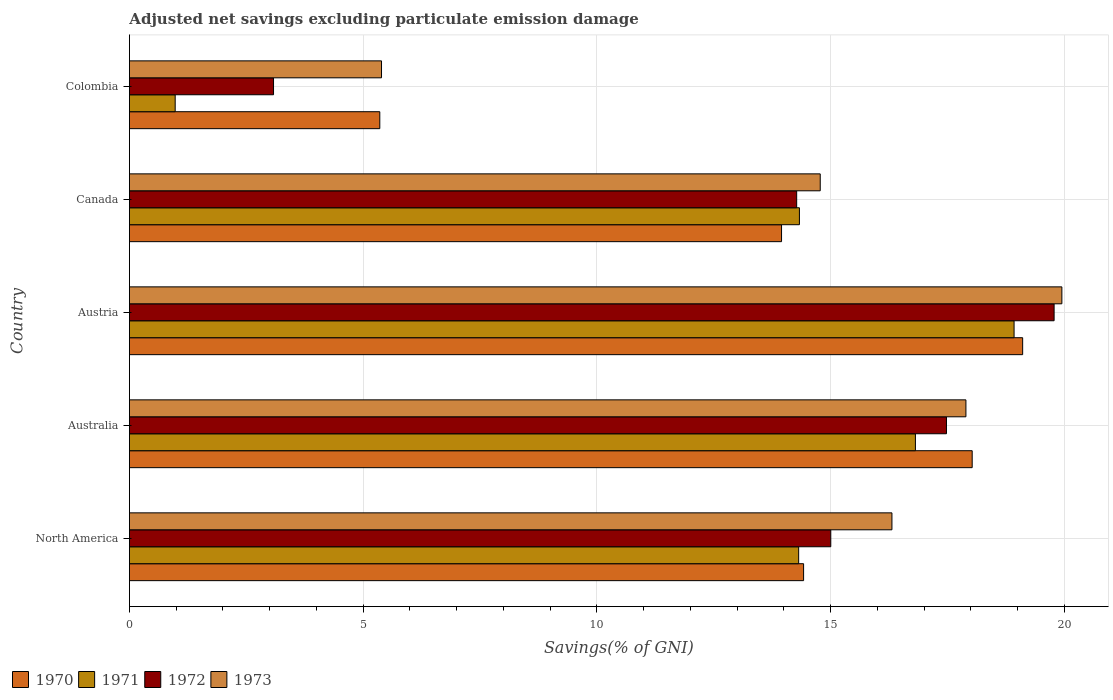Are the number of bars per tick equal to the number of legend labels?
Keep it short and to the point. Yes. In how many cases, is the number of bars for a given country not equal to the number of legend labels?
Keep it short and to the point. 0. What is the adjusted net savings in 1970 in Australia?
Offer a terse response. 18.03. Across all countries, what is the maximum adjusted net savings in 1970?
Provide a succinct answer. 19.11. Across all countries, what is the minimum adjusted net savings in 1973?
Make the answer very short. 5.39. What is the total adjusted net savings in 1973 in the graph?
Your answer should be compact. 74.32. What is the difference between the adjusted net savings in 1971 in Austria and that in Canada?
Provide a succinct answer. 4.59. What is the difference between the adjusted net savings in 1972 in Austria and the adjusted net savings in 1970 in Canada?
Give a very brief answer. 5.83. What is the average adjusted net savings in 1973 per country?
Ensure brevity in your answer.  14.86. What is the difference between the adjusted net savings in 1971 and adjusted net savings in 1972 in Australia?
Ensure brevity in your answer.  -0.66. In how many countries, is the adjusted net savings in 1973 greater than 2 %?
Ensure brevity in your answer.  5. What is the ratio of the adjusted net savings in 1973 in Australia to that in Austria?
Provide a short and direct response. 0.9. Is the adjusted net savings in 1971 in Colombia less than that in North America?
Offer a very short reply. Yes. What is the difference between the highest and the second highest adjusted net savings in 1973?
Keep it short and to the point. 2.05. What is the difference between the highest and the lowest adjusted net savings in 1970?
Make the answer very short. 13.75. Is the sum of the adjusted net savings in 1973 in Australia and Colombia greater than the maximum adjusted net savings in 1971 across all countries?
Keep it short and to the point. Yes. Is it the case that in every country, the sum of the adjusted net savings in 1973 and adjusted net savings in 1972 is greater than the sum of adjusted net savings in 1971 and adjusted net savings in 1970?
Make the answer very short. No. What does the 2nd bar from the bottom in Austria represents?
Your answer should be compact. 1971. Does the graph contain any zero values?
Give a very brief answer. No. Does the graph contain grids?
Your answer should be compact. Yes. Where does the legend appear in the graph?
Make the answer very short. Bottom left. How many legend labels are there?
Make the answer very short. 4. How are the legend labels stacked?
Provide a succinct answer. Horizontal. What is the title of the graph?
Give a very brief answer. Adjusted net savings excluding particulate emission damage. What is the label or title of the X-axis?
Your response must be concise. Savings(% of GNI). What is the Savings(% of GNI) of 1970 in North America?
Make the answer very short. 14.42. What is the Savings(% of GNI) in 1971 in North America?
Provide a short and direct response. 14.31. What is the Savings(% of GNI) of 1972 in North America?
Offer a terse response. 15. What is the Savings(% of GNI) of 1973 in North America?
Provide a short and direct response. 16.31. What is the Savings(% of GNI) in 1970 in Australia?
Provide a short and direct response. 18.03. What is the Savings(% of GNI) of 1971 in Australia?
Give a very brief answer. 16.81. What is the Savings(% of GNI) in 1972 in Australia?
Your answer should be compact. 17.48. What is the Savings(% of GNI) in 1973 in Australia?
Your answer should be compact. 17.89. What is the Savings(% of GNI) of 1970 in Austria?
Your response must be concise. 19.11. What is the Savings(% of GNI) of 1971 in Austria?
Give a very brief answer. 18.92. What is the Savings(% of GNI) of 1972 in Austria?
Your answer should be compact. 19.78. What is the Savings(% of GNI) in 1973 in Austria?
Give a very brief answer. 19.94. What is the Savings(% of GNI) of 1970 in Canada?
Give a very brief answer. 13.95. What is the Savings(% of GNI) in 1971 in Canada?
Your answer should be compact. 14.33. What is the Savings(% of GNI) of 1972 in Canada?
Provide a short and direct response. 14.27. What is the Savings(% of GNI) in 1973 in Canada?
Give a very brief answer. 14.78. What is the Savings(% of GNI) in 1970 in Colombia?
Give a very brief answer. 5.36. What is the Savings(% of GNI) in 1971 in Colombia?
Offer a very short reply. 0.98. What is the Savings(% of GNI) of 1972 in Colombia?
Your response must be concise. 3.08. What is the Savings(% of GNI) in 1973 in Colombia?
Offer a very short reply. 5.39. Across all countries, what is the maximum Savings(% of GNI) of 1970?
Provide a short and direct response. 19.11. Across all countries, what is the maximum Savings(% of GNI) in 1971?
Your answer should be very brief. 18.92. Across all countries, what is the maximum Savings(% of GNI) of 1972?
Offer a terse response. 19.78. Across all countries, what is the maximum Savings(% of GNI) of 1973?
Your response must be concise. 19.94. Across all countries, what is the minimum Savings(% of GNI) in 1970?
Give a very brief answer. 5.36. Across all countries, what is the minimum Savings(% of GNI) of 1971?
Give a very brief answer. 0.98. Across all countries, what is the minimum Savings(% of GNI) of 1972?
Provide a short and direct response. 3.08. Across all countries, what is the minimum Savings(% of GNI) in 1973?
Ensure brevity in your answer.  5.39. What is the total Savings(% of GNI) of 1970 in the graph?
Offer a terse response. 70.86. What is the total Savings(% of GNI) in 1971 in the graph?
Offer a very short reply. 65.36. What is the total Savings(% of GNI) of 1972 in the graph?
Keep it short and to the point. 69.61. What is the total Savings(% of GNI) in 1973 in the graph?
Provide a succinct answer. 74.32. What is the difference between the Savings(% of GNI) of 1970 in North America and that in Australia?
Keep it short and to the point. -3.61. What is the difference between the Savings(% of GNI) of 1971 in North America and that in Australia?
Offer a very short reply. -2.5. What is the difference between the Savings(% of GNI) in 1972 in North America and that in Australia?
Offer a very short reply. -2.47. What is the difference between the Savings(% of GNI) in 1973 in North America and that in Australia?
Offer a very short reply. -1.58. What is the difference between the Savings(% of GNI) of 1970 in North America and that in Austria?
Offer a very short reply. -4.69. What is the difference between the Savings(% of GNI) of 1971 in North America and that in Austria?
Make the answer very short. -4.61. What is the difference between the Savings(% of GNI) in 1972 in North America and that in Austria?
Your response must be concise. -4.78. What is the difference between the Savings(% of GNI) in 1973 in North America and that in Austria?
Give a very brief answer. -3.63. What is the difference between the Savings(% of GNI) in 1970 in North America and that in Canada?
Provide a short and direct response. 0.47. What is the difference between the Savings(% of GNI) in 1971 in North America and that in Canada?
Give a very brief answer. -0.02. What is the difference between the Savings(% of GNI) in 1972 in North America and that in Canada?
Ensure brevity in your answer.  0.73. What is the difference between the Savings(% of GNI) in 1973 in North America and that in Canada?
Offer a terse response. 1.53. What is the difference between the Savings(% of GNI) of 1970 in North America and that in Colombia?
Offer a very short reply. 9.06. What is the difference between the Savings(% of GNI) in 1971 in North America and that in Colombia?
Provide a succinct answer. 13.34. What is the difference between the Savings(% of GNI) in 1972 in North America and that in Colombia?
Your answer should be very brief. 11.92. What is the difference between the Savings(% of GNI) of 1973 in North America and that in Colombia?
Provide a short and direct response. 10.92. What is the difference between the Savings(% of GNI) in 1970 in Australia and that in Austria?
Offer a very short reply. -1.08. What is the difference between the Savings(% of GNI) of 1971 in Australia and that in Austria?
Provide a succinct answer. -2.11. What is the difference between the Savings(% of GNI) in 1972 in Australia and that in Austria?
Ensure brevity in your answer.  -2.3. What is the difference between the Savings(% of GNI) of 1973 in Australia and that in Austria?
Your answer should be very brief. -2.05. What is the difference between the Savings(% of GNI) of 1970 in Australia and that in Canada?
Ensure brevity in your answer.  4.08. What is the difference between the Savings(% of GNI) in 1971 in Australia and that in Canada?
Make the answer very short. 2.48. What is the difference between the Savings(% of GNI) of 1972 in Australia and that in Canada?
Your answer should be compact. 3.2. What is the difference between the Savings(% of GNI) in 1973 in Australia and that in Canada?
Keep it short and to the point. 3.12. What is the difference between the Savings(% of GNI) in 1970 in Australia and that in Colombia?
Offer a very short reply. 12.67. What is the difference between the Savings(% of GNI) of 1971 in Australia and that in Colombia?
Offer a very short reply. 15.83. What is the difference between the Savings(% of GNI) of 1972 in Australia and that in Colombia?
Your response must be concise. 14.39. What is the difference between the Savings(% of GNI) of 1973 in Australia and that in Colombia?
Ensure brevity in your answer.  12.5. What is the difference between the Savings(% of GNI) of 1970 in Austria and that in Canada?
Provide a succinct answer. 5.16. What is the difference between the Savings(% of GNI) in 1971 in Austria and that in Canada?
Your answer should be compact. 4.59. What is the difference between the Savings(% of GNI) in 1972 in Austria and that in Canada?
Provide a succinct answer. 5.51. What is the difference between the Savings(% of GNI) in 1973 in Austria and that in Canada?
Provide a succinct answer. 5.17. What is the difference between the Savings(% of GNI) in 1970 in Austria and that in Colombia?
Ensure brevity in your answer.  13.75. What is the difference between the Savings(% of GNI) in 1971 in Austria and that in Colombia?
Your answer should be very brief. 17.94. What is the difference between the Savings(% of GNI) in 1972 in Austria and that in Colombia?
Your answer should be very brief. 16.7. What is the difference between the Savings(% of GNI) in 1973 in Austria and that in Colombia?
Give a very brief answer. 14.55. What is the difference between the Savings(% of GNI) in 1970 in Canada and that in Colombia?
Your answer should be very brief. 8.59. What is the difference between the Savings(% of GNI) in 1971 in Canada and that in Colombia?
Your response must be concise. 13.35. What is the difference between the Savings(% of GNI) of 1972 in Canada and that in Colombia?
Give a very brief answer. 11.19. What is the difference between the Savings(% of GNI) of 1973 in Canada and that in Colombia?
Keep it short and to the point. 9.38. What is the difference between the Savings(% of GNI) of 1970 in North America and the Savings(% of GNI) of 1971 in Australia?
Give a very brief answer. -2.39. What is the difference between the Savings(% of GNI) in 1970 in North America and the Savings(% of GNI) in 1972 in Australia?
Provide a short and direct response. -3.06. What is the difference between the Savings(% of GNI) in 1970 in North America and the Savings(% of GNI) in 1973 in Australia?
Offer a very short reply. -3.47. What is the difference between the Savings(% of GNI) of 1971 in North America and the Savings(% of GNI) of 1972 in Australia?
Your answer should be very brief. -3.16. What is the difference between the Savings(% of GNI) in 1971 in North America and the Savings(% of GNI) in 1973 in Australia?
Your response must be concise. -3.58. What is the difference between the Savings(% of GNI) of 1972 in North America and the Savings(% of GNI) of 1973 in Australia?
Make the answer very short. -2.89. What is the difference between the Savings(% of GNI) of 1970 in North America and the Savings(% of GNI) of 1971 in Austria?
Provide a short and direct response. -4.5. What is the difference between the Savings(% of GNI) of 1970 in North America and the Savings(% of GNI) of 1972 in Austria?
Keep it short and to the point. -5.36. What is the difference between the Savings(% of GNI) of 1970 in North America and the Savings(% of GNI) of 1973 in Austria?
Provide a short and direct response. -5.52. What is the difference between the Savings(% of GNI) of 1971 in North America and the Savings(% of GNI) of 1972 in Austria?
Provide a short and direct response. -5.46. What is the difference between the Savings(% of GNI) of 1971 in North America and the Savings(% of GNI) of 1973 in Austria?
Keep it short and to the point. -5.63. What is the difference between the Savings(% of GNI) in 1972 in North America and the Savings(% of GNI) in 1973 in Austria?
Provide a succinct answer. -4.94. What is the difference between the Savings(% of GNI) in 1970 in North America and the Savings(% of GNI) in 1971 in Canada?
Your answer should be very brief. 0.09. What is the difference between the Savings(% of GNI) of 1970 in North America and the Savings(% of GNI) of 1972 in Canada?
Keep it short and to the point. 0.15. What is the difference between the Savings(% of GNI) in 1970 in North America and the Savings(% of GNI) in 1973 in Canada?
Keep it short and to the point. -0.36. What is the difference between the Savings(% of GNI) in 1971 in North America and the Savings(% of GNI) in 1972 in Canada?
Provide a succinct answer. 0.04. What is the difference between the Savings(% of GNI) of 1971 in North America and the Savings(% of GNI) of 1973 in Canada?
Offer a terse response. -0.46. What is the difference between the Savings(% of GNI) of 1972 in North America and the Savings(% of GNI) of 1973 in Canada?
Provide a short and direct response. 0.23. What is the difference between the Savings(% of GNI) of 1970 in North America and the Savings(% of GNI) of 1971 in Colombia?
Ensure brevity in your answer.  13.44. What is the difference between the Savings(% of GNI) of 1970 in North America and the Savings(% of GNI) of 1972 in Colombia?
Your response must be concise. 11.34. What is the difference between the Savings(% of GNI) of 1970 in North America and the Savings(% of GNI) of 1973 in Colombia?
Provide a succinct answer. 9.03. What is the difference between the Savings(% of GNI) of 1971 in North America and the Savings(% of GNI) of 1972 in Colombia?
Offer a very short reply. 11.23. What is the difference between the Savings(% of GNI) in 1971 in North America and the Savings(% of GNI) in 1973 in Colombia?
Your answer should be compact. 8.92. What is the difference between the Savings(% of GNI) of 1972 in North America and the Savings(% of GNI) of 1973 in Colombia?
Offer a terse response. 9.61. What is the difference between the Savings(% of GNI) in 1970 in Australia and the Savings(% of GNI) in 1971 in Austria?
Ensure brevity in your answer.  -0.9. What is the difference between the Savings(% of GNI) of 1970 in Australia and the Savings(% of GNI) of 1972 in Austria?
Your answer should be compact. -1.75. What is the difference between the Savings(% of GNI) of 1970 in Australia and the Savings(% of GNI) of 1973 in Austria?
Offer a terse response. -1.92. What is the difference between the Savings(% of GNI) of 1971 in Australia and the Savings(% of GNI) of 1972 in Austria?
Ensure brevity in your answer.  -2.97. What is the difference between the Savings(% of GNI) of 1971 in Australia and the Savings(% of GNI) of 1973 in Austria?
Your answer should be compact. -3.13. What is the difference between the Savings(% of GNI) in 1972 in Australia and the Savings(% of GNI) in 1973 in Austria?
Give a very brief answer. -2.47. What is the difference between the Savings(% of GNI) in 1970 in Australia and the Savings(% of GNI) in 1971 in Canada?
Provide a succinct answer. 3.7. What is the difference between the Savings(% of GNI) of 1970 in Australia and the Savings(% of GNI) of 1972 in Canada?
Provide a succinct answer. 3.75. What is the difference between the Savings(% of GNI) in 1970 in Australia and the Savings(% of GNI) in 1973 in Canada?
Provide a short and direct response. 3.25. What is the difference between the Savings(% of GNI) of 1971 in Australia and the Savings(% of GNI) of 1972 in Canada?
Offer a terse response. 2.54. What is the difference between the Savings(% of GNI) in 1971 in Australia and the Savings(% of GNI) in 1973 in Canada?
Keep it short and to the point. 2.04. What is the difference between the Savings(% of GNI) in 1972 in Australia and the Savings(% of GNI) in 1973 in Canada?
Offer a very short reply. 2.7. What is the difference between the Savings(% of GNI) in 1970 in Australia and the Savings(% of GNI) in 1971 in Colombia?
Offer a terse response. 17.05. What is the difference between the Savings(% of GNI) of 1970 in Australia and the Savings(% of GNI) of 1972 in Colombia?
Keep it short and to the point. 14.94. What is the difference between the Savings(% of GNI) in 1970 in Australia and the Savings(% of GNI) in 1973 in Colombia?
Offer a terse response. 12.63. What is the difference between the Savings(% of GNI) of 1971 in Australia and the Savings(% of GNI) of 1972 in Colombia?
Your answer should be very brief. 13.73. What is the difference between the Savings(% of GNI) in 1971 in Australia and the Savings(% of GNI) in 1973 in Colombia?
Make the answer very short. 11.42. What is the difference between the Savings(% of GNI) in 1972 in Australia and the Savings(% of GNI) in 1973 in Colombia?
Make the answer very short. 12.08. What is the difference between the Savings(% of GNI) in 1970 in Austria and the Savings(% of GNI) in 1971 in Canada?
Your answer should be compact. 4.77. What is the difference between the Savings(% of GNI) in 1970 in Austria and the Savings(% of GNI) in 1972 in Canada?
Ensure brevity in your answer.  4.83. What is the difference between the Savings(% of GNI) of 1970 in Austria and the Savings(% of GNI) of 1973 in Canada?
Offer a very short reply. 4.33. What is the difference between the Savings(% of GNI) in 1971 in Austria and the Savings(% of GNI) in 1972 in Canada?
Provide a short and direct response. 4.65. What is the difference between the Savings(% of GNI) in 1971 in Austria and the Savings(% of GNI) in 1973 in Canada?
Make the answer very short. 4.15. What is the difference between the Savings(% of GNI) in 1972 in Austria and the Savings(% of GNI) in 1973 in Canada?
Provide a short and direct response. 5. What is the difference between the Savings(% of GNI) of 1970 in Austria and the Savings(% of GNI) of 1971 in Colombia?
Make the answer very short. 18.13. What is the difference between the Savings(% of GNI) in 1970 in Austria and the Savings(% of GNI) in 1972 in Colombia?
Your response must be concise. 16.02. What is the difference between the Savings(% of GNI) in 1970 in Austria and the Savings(% of GNI) in 1973 in Colombia?
Your answer should be very brief. 13.71. What is the difference between the Savings(% of GNI) in 1971 in Austria and the Savings(% of GNI) in 1972 in Colombia?
Your answer should be very brief. 15.84. What is the difference between the Savings(% of GNI) in 1971 in Austria and the Savings(% of GNI) in 1973 in Colombia?
Offer a terse response. 13.53. What is the difference between the Savings(% of GNI) in 1972 in Austria and the Savings(% of GNI) in 1973 in Colombia?
Your answer should be compact. 14.39. What is the difference between the Savings(% of GNI) of 1970 in Canada and the Savings(% of GNI) of 1971 in Colombia?
Offer a very short reply. 12.97. What is the difference between the Savings(% of GNI) of 1970 in Canada and the Savings(% of GNI) of 1972 in Colombia?
Give a very brief answer. 10.87. What is the difference between the Savings(% of GNI) in 1970 in Canada and the Savings(% of GNI) in 1973 in Colombia?
Provide a short and direct response. 8.56. What is the difference between the Savings(% of GNI) in 1971 in Canada and the Savings(% of GNI) in 1972 in Colombia?
Offer a very short reply. 11.25. What is the difference between the Savings(% of GNI) of 1971 in Canada and the Savings(% of GNI) of 1973 in Colombia?
Your response must be concise. 8.94. What is the difference between the Savings(% of GNI) in 1972 in Canada and the Savings(% of GNI) in 1973 in Colombia?
Keep it short and to the point. 8.88. What is the average Savings(% of GNI) in 1970 per country?
Make the answer very short. 14.17. What is the average Savings(% of GNI) in 1971 per country?
Provide a short and direct response. 13.07. What is the average Savings(% of GNI) in 1972 per country?
Your response must be concise. 13.92. What is the average Savings(% of GNI) of 1973 per country?
Keep it short and to the point. 14.86. What is the difference between the Savings(% of GNI) in 1970 and Savings(% of GNI) in 1971 in North America?
Offer a terse response. 0.11. What is the difference between the Savings(% of GNI) in 1970 and Savings(% of GNI) in 1972 in North America?
Offer a very short reply. -0.58. What is the difference between the Savings(% of GNI) in 1970 and Savings(% of GNI) in 1973 in North America?
Provide a succinct answer. -1.89. What is the difference between the Savings(% of GNI) of 1971 and Savings(% of GNI) of 1972 in North America?
Offer a very short reply. -0.69. What is the difference between the Savings(% of GNI) of 1971 and Savings(% of GNI) of 1973 in North America?
Your answer should be compact. -2. What is the difference between the Savings(% of GNI) in 1972 and Savings(% of GNI) in 1973 in North America?
Offer a very short reply. -1.31. What is the difference between the Savings(% of GNI) in 1970 and Savings(% of GNI) in 1971 in Australia?
Ensure brevity in your answer.  1.21. What is the difference between the Savings(% of GNI) in 1970 and Savings(% of GNI) in 1972 in Australia?
Make the answer very short. 0.55. What is the difference between the Savings(% of GNI) of 1970 and Savings(% of GNI) of 1973 in Australia?
Offer a very short reply. 0.13. What is the difference between the Savings(% of GNI) in 1971 and Savings(% of GNI) in 1972 in Australia?
Offer a terse response. -0.66. What is the difference between the Savings(% of GNI) in 1971 and Savings(% of GNI) in 1973 in Australia?
Give a very brief answer. -1.08. What is the difference between the Savings(% of GNI) of 1972 and Savings(% of GNI) of 1973 in Australia?
Keep it short and to the point. -0.42. What is the difference between the Savings(% of GNI) in 1970 and Savings(% of GNI) in 1971 in Austria?
Your response must be concise. 0.18. What is the difference between the Savings(% of GNI) in 1970 and Savings(% of GNI) in 1972 in Austria?
Your answer should be very brief. -0.67. What is the difference between the Savings(% of GNI) in 1970 and Savings(% of GNI) in 1973 in Austria?
Make the answer very short. -0.84. What is the difference between the Savings(% of GNI) of 1971 and Savings(% of GNI) of 1972 in Austria?
Make the answer very short. -0.86. What is the difference between the Savings(% of GNI) in 1971 and Savings(% of GNI) in 1973 in Austria?
Give a very brief answer. -1.02. What is the difference between the Savings(% of GNI) of 1972 and Savings(% of GNI) of 1973 in Austria?
Keep it short and to the point. -0.17. What is the difference between the Savings(% of GNI) of 1970 and Savings(% of GNI) of 1971 in Canada?
Offer a very short reply. -0.38. What is the difference between the Savings(% of GNI) in 1970 and Savings(% of GNI) in 1972 in Canada?
Your response must be concise. -0.32. What is the difference between the Savings(% of GNI) in 1970 and Savings(% of GNI) in 1973 in Canada?
Your answer should be very brief. -0.83. What is the difference between the Savings(% of GNI) of 1971 and Savings(% of GNI) of 1972 in Canada?
Keep it short and to the point. 0.06. What is the difference between the Savings(% of GNI) in 1971 and Savings(% of GNI) in 1973 in Canada?
Keep it short and to the point. -0.45. What is the difference between the Savings(% of GNI) in 1972 and Savings(% of GNI) in 1973 in Canada?
Your answer should be very brief. -0.5. What is the difference between the Savings(% of GNI) of 1970 and Savings(% of GNI) of 1971 in Colombia?
Ensure brevity in your answer.  4.38. What is the difference between the Savings(% of GNI) in 1970 and Savings(% of GNI) in 1972 in Colombia?
Make the answer very short. 2.27. What is the difference between the Savings(% of GNI) in 1970 and Savings(% of GNI) in 1973 in Colombia?
Provide a short and direct response. -0.04. What is the difference between the Savings(% of GNI) of 1971 and Savings(% of GNI) of 1972 in Colombia?
Offer a very short reply. -2.1. What is the difference between the Savings(% of GNI) in 1971 and Savings(% of GNI) in 1973 in Colombia?
Offer a very short reply. -4.41. What is the difference between the Savings(% of GNI) in 1972 and Savings(% of GNI) in 1973 in Colombia?
Ensure brevity in your answer.  -2.31. What is the ratio of the Savings(% of GNI) of 1970 in North America to that in Australia?
Give a very brief answer. 0.8. What is the ratio of the Savings(% of GNI) of 1971 in North America to that in Australia?
Give a very brief answer. 0.85. What is the ratio of the Savings(% of GNI) of 1972 in North America to that in Australia?
Your response must be concise. 0.86. What is the ratio of the Savings(% of GNI) in 1973 in North America to that in Australia?
Provide a succinct answer. 0.91. What is the ratio of the Savings(% of GNI) in 1970 in North America to that in Austria?
Offer a terse response. 0.75. What is the ratio of the Savings(% of GNI) in 1971 in North America to that in Austria?
Your answer should be very brief. 0.76. What is the ratio of the Savings(% of GNI) in 1972 in North America to that in Austria?
Give a very brief answer. 0.76. What is the ratio of the Savings(% of GNI) in 1973 in North America to that in Austria?
Your response must be concise. 0.82. What is the ratio of the Savings(% of GNI) of 1970 in North America to that in Canada?
Make the answer very short. 1.03. What is the ratio of the Savings(% of GNI) in 1972 in North America to that in Canada?
Give a very brief answer. 1.05. What is the ratio of the Savings(% of GNI) of 1973 in North America to that in Canada?
Give a very brief answer. 1.1. What is the ratio of the Savings(% of GNI) of 1970 in North America to that in Colombia?
Your response must be concise. 2.69. What is the ratio of the Savings(% of GNI) in 1971 in North America to that in Colombia?
Give a very brief answer. 14.62. What is the ratio of the Savings(% of GNI) of 1972 in North America to that in Colombia?
Offer a very short reply. 4.87. What is the ratio of the Savings(% of GNI) in 1973 in North America to that in Colombia?
Your answer should be very brief. 3.02. What is the ratio of the Savings(% of GNI) of 1970 in Australia to that in Austria?
Provide a short and direct response. 0.94. What is the ratio of the Savings(% of GNI) in 1971 in Australia to that in Austria?
Offer a terse response. 0.89. What is the ratio of the Savings(% of GNI) in 1972 in Australia to that in Austria?
Keep it short and to the point. 0.88. What is the ratio of the Savings(% of GNI) of 1973 in Australia to that in Austria?
Provide a succinct answer. 0.9. What is the ratio of the Savings(% of GNI) of 1970 in Australia to that in Canada?
Provide a succinct answer. 1.29. What is the ratio of the Savings(% of GNI) of 1971 in Australia to that in Canada?
Keep it short and to the point. 1.17. What is the ratio of the Savings(% of GNI) in 1972 in Australia to that in Canada?
Offer a very short reply. 1.22. What is the ratio of the Savings(% of GNI) in 1973 in Australia to that in Canada?
Your response must be concise. 1.21. What is the ratio of the Savings(% of GNI) of 1970 in Australia to that in Colombia?
Keep it short and to the point. 3.37. What is the ratio of the Savings(% of GNI) in 1971 in Australia to that in Colombia?
Keep it short and to the point. 17.17. What is the ratio of the Savings(% of GNI) of 1972 in Australia to that in Colombia?
Keep it short and to the point. 5.67. What is the ratio of the Savings(% of GNI) of 1973 in Australia to that in Colombia?
Ensure brevity in your answer.  3.32. What is the ratio of the Savings(% of GNI) in 1970 in Austria to that in Canada?
Provide a short and direct response. 1.37. What is the ratio of the Savings(% of GNI) of 1971 in Austria to that in Canada?
Offer a terse response. 1.32. What is the ratio of the Savings(% of GNI) in 1972 in Austria to that in Canada?
Provide a short and direct response. 1.39. What is the ratio of the Savings(% of GNI) of 1973 in Austria to that in Canada?
Ensure brevity in your answer.  1.35. What is the ratio of the Savings(% of GNI) of 1970 in Austria to that in Colombia?
Offer a terse response. 3.57. What is the ratio of the Savings(% of GNI) in 1971 in Austria to that in Colombia?
Ensure brevity in your answer.  19.32. What is the ratio of the Savings(% of GNI) of 1972 in Austria to that in Colombia?
Provide a succinct answer. 6.42. What is the ratio of the Savings(% of GNI) of 1973 in Austria to that in Colombia?
Your response must be concise. 3.7. What is the ratio of the Savings(% of GNI) of 1970 in Canada to that in Colombia?
Your answer should be very brief. 2.6. What is the ratio of the Savings(% of GNI) of 1971 in Canada to that in Colombia?
Offer a very short reply. 14.64. What is the ratio of the Savings(% of GNI) in 1972 in Canada to that in Colombia?
Make the answer very short. 4.63. What is the ratio of the Savings(% of GNI) of 1973 in Canada to that in Colombia?
Offer a very short reply. 2.74. What is the difference between the highest and the second highest Savings(% of GNI) of 1970?
Your answer should be very brief. 1.08. What is the difference between the highest and the second highest Savings(% of GNI) of 1971?
Offer a very short reply. 2.11. What is the difference between the highest and the second highest Savings(% of GNI) of 1972?
Provide a succinct answer. 2.3. What is the difference between the highest and the second highest Savings(% of GNI) in 1973?
Provide a succinct answer. 2.05. What is the difference between the highest and the lowest Savings(% of GNI) in 1970?
Make the answer very short. 13.75. What is the difference between the highest and the lowest Savings(% of GNI) of 1971?
Your answer should be compact. 17.94. What is the difference between the highest and the lowest Savings(% of GNI) of 1972?
Make the answer very short. 16.7. What is the difference between the highest and the lowest Savings(% of GNI) in 1973?
Offer a terse response. 14.55. 